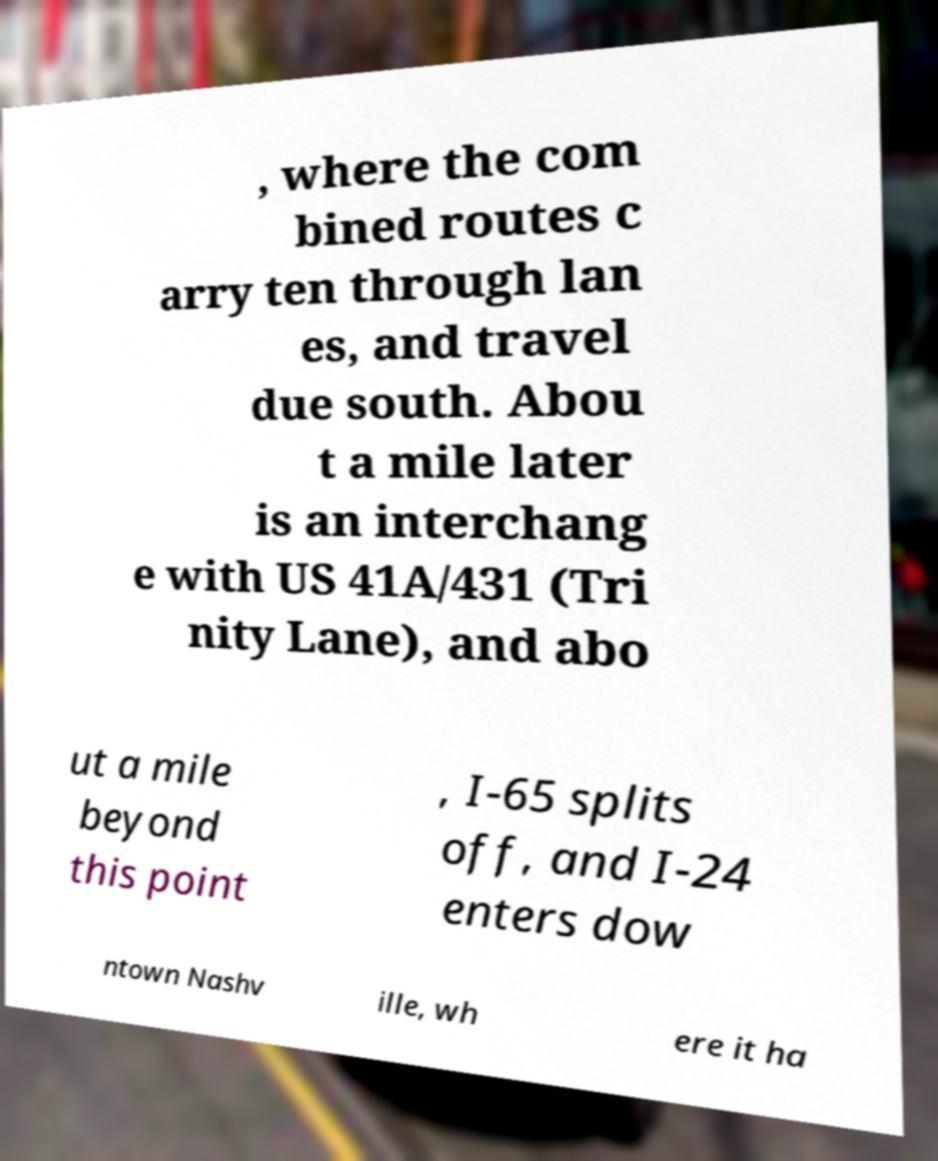Can you read and provide the text displayed in the image?This photo seems to have some interesting text. Can you extract and type it out for me? , where the com bined routes c arry ten through lan es, and travel due south. Abou t a mile later is an interchang e with US 41A/431 (Tri nity Lane), and abo ut a mile beyond this point , I-65 splits off, and I-24 enters dow ntown Nashv ille, wh ere it ha 